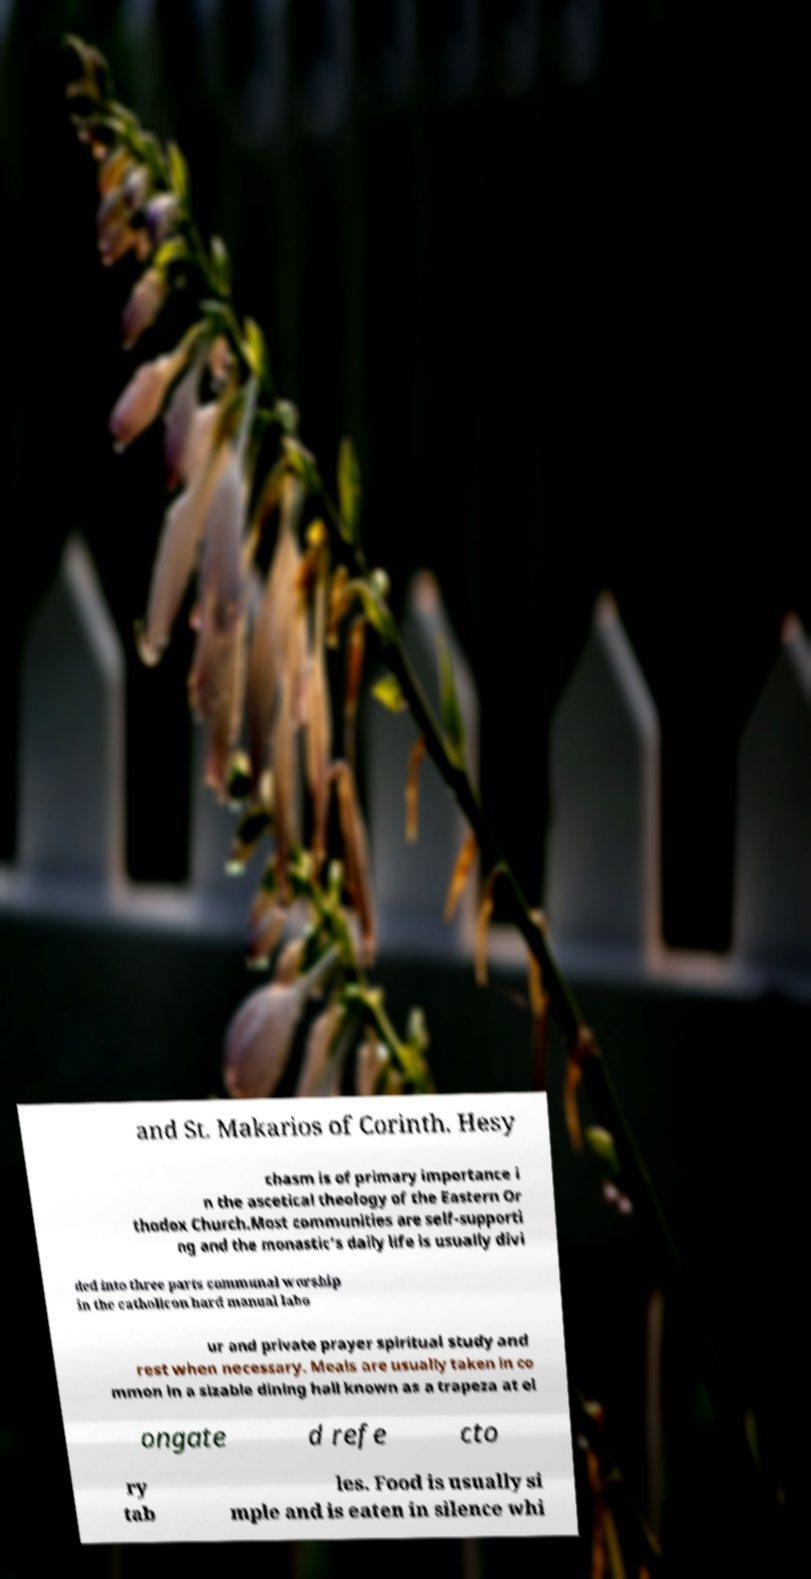Please read and relay the text visible in this image. What does it say? and St. Makarios of Corinth. Hesy chasm is of primary importance i n the ascetical theology of the Eastern Or thodox Church.Most communities are self-supporti ng and the monastic's daily life is usually divi ded into three parts communal worship in the catholicon hard manual labo ur and private prayer spiritual study and rest when necessary. Meals are usually taken in co mmon in a sizable dining hall known as a trapeza at el ongate d refe cto ry tab les. Food is usually si mple and is eaten in silence whi 